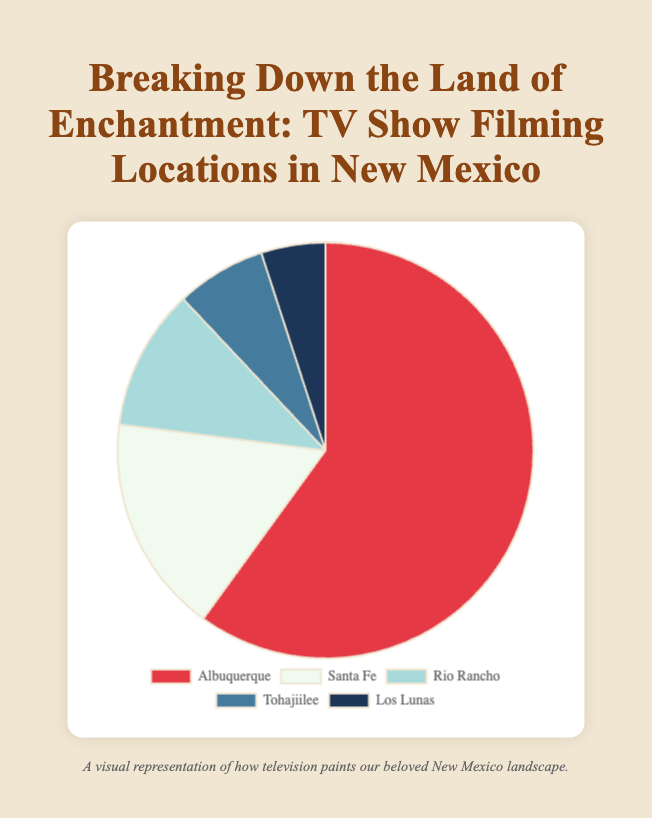What location has the highest percentage of episodes filmed? The pie chart shows the percentage of episodes filmed in different locations. Albuquerque has the largest slice with 60%.
Answer: Albuquerque Which location has the lowest percentage of episodes filmed? The pie chart shows the breakdown of percentages, with Los Lunas having the smallest slice at 5%.
Answer: Los Lunas How many episodes were filmed in Santa Fe and Rio Rancho combined? The pie chart data shows 12 episodes in Santa Fe and 8 episodes in Rio Rancho. Adding them together gives 12 + 8 = 20.
Answer: 20 What is the percentage difference between Albuquerque and Tohajiilee? Albuquerque has 60% and Tohajiilee has 7%. The difference is 60% - 7% = 53%.
Answer: 53% Which location had more episodes filmed, Tohajiilee or Los Lunas, and by how many? Tohajiilee had 5 episodes filmed while Los Lunas had 3. The difference is 5 - 3 = 2 episodes. Tohajiilee had more episodes filmed by 2.
Answer: Tohajiilee, by 2 What are the combined percentages of episodes filmed in Rio Rancho and Los Lunas? Rio Rancho has 11% and Los Lunas has 5%. Adding them together gives 11% + 5% = 16%.
Answer: 16% Among the presented locations, which one contributes the second highest percentage of episodes? The pie chart shows the second largest slice belongs to Santa Fe with 17%.
Answer: Santa Fe If a new location were added with 5% of the episodes, how would this affect the percentage of episodes filmed in Albuquerque? The total percentage including the new location would be 100% + 5% = 105%. The new percentage for Albuquerque would be recalculated as (60/105)*100. Therefore, the new percentage for Albuquerque would be approximately 57.14%.
Answer: 57.14% What visual attributes help indicate the most significant location for filming? The largest slice of the pie chart, colored red, visually dominates the chart, indicating it represents the most significant filming location.
Answer: Largest slice, red What is the ratio of episodes filmed in Albuquerque to episodes filmed in Tohajiilee? Albuquerque has 42 episodes, and Tohajiilee has 5. The ratio is 42:5, which simplifies to 42/5 or 8.4:1.
Answer: 8.4:1 